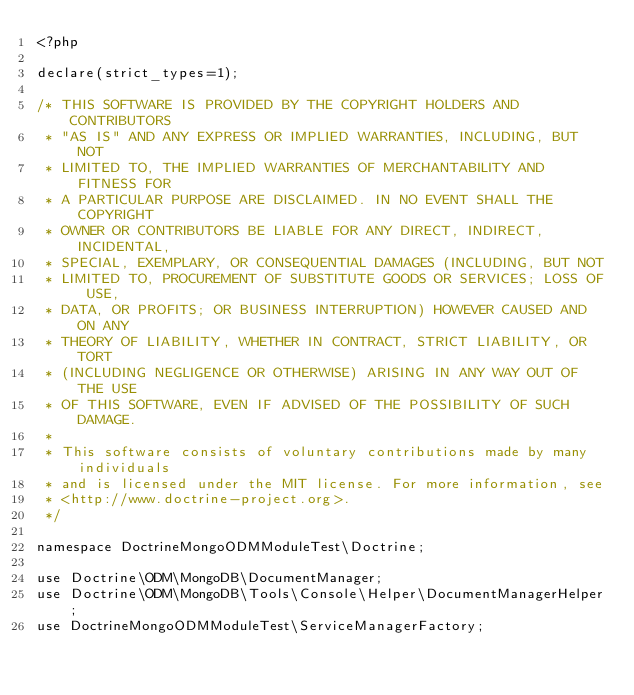Convert code to text. <code><loc_0><loc_0><loc_500><loc_500><_PHP_><?php

declare(strict_types=1);

/* THIS SOFTWARE IS PROVIDED BY THE COPYRIGHT HOLDERS AND CONTRIBUTORS
 * "AS IS" AND ANY EXPRESS OR IMPLIED WARRANTIES, INCLUDING, BUT NOT
 * LIMITED TO, THE IMPLIED WARRANTIES OF MERCHANTABILITY AND FITNESS FOR
 * A PARTICULAR PURPOSE ARE DISCLAIMED. IN NO EVENT SHALL THE COPYRIGHT
 * OWNER OR CONTRIBUTORS BE LIABLE FOR ANY DIRECT, INDIRECT, INCIDENTAL,
 * SPECIAL, EXEMPLARY, OR CONSEQUENTIAL DAMAGES (INCLUDING, BUT NOT
 * LIMITED TO, PROCUREMENT OF SUBSTITUTE GOODS OR SERVICES; LOSS OF USE,
 * DATA, OR PROFITS; OR BUSINESS INTERRUPTION) HOWEVER CAUSED AND ON ANY
 * THEORY OF LIABILITY, WHETHER IN CONTRACT, STRICT LIABILITY, OR TORT
 * (INCLUDING NEGLIGENCE OR OTHERWISE) ARISING IN ANY WAY OUT OF THE USE
 * OF THIS SOFTWARE, EVEN IF ADVISED OF THE POSSIBILITY OF SUCH DAMAGE.
 *
 * This software consists of voluntary contributions made by many individuals
 * and is licensed under the MIT license. For more information, see
 * <http://www.doctrine-project.org>.
 */

namespace DoctrineMongoODMModuleTest\Doctrine;

use Doctrine\ODM\MongoDB\DocumentManager;
use Doctrine\ODM\MongoDB\Tools\Console\Helper\DocumentManagerHelper;
use DoctrineMongoODMModuleTest\ServiceManagerFactory;</code> 